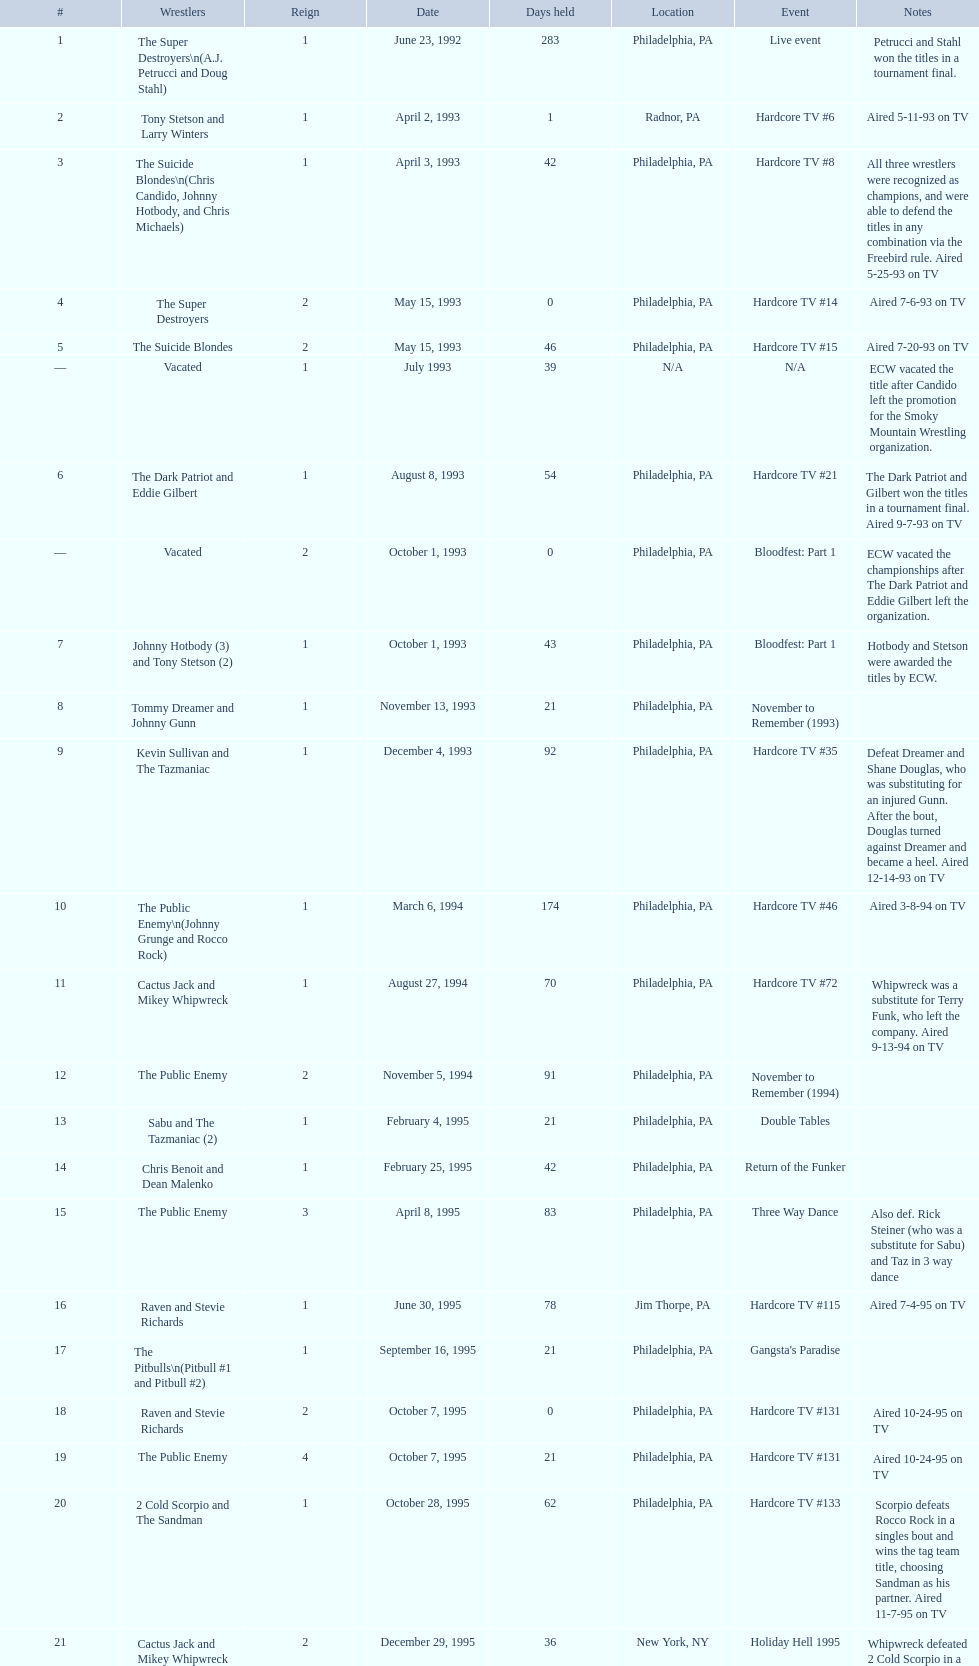What comes after hardcore tv #15 in the event sequence? Hardcore TV #21. 